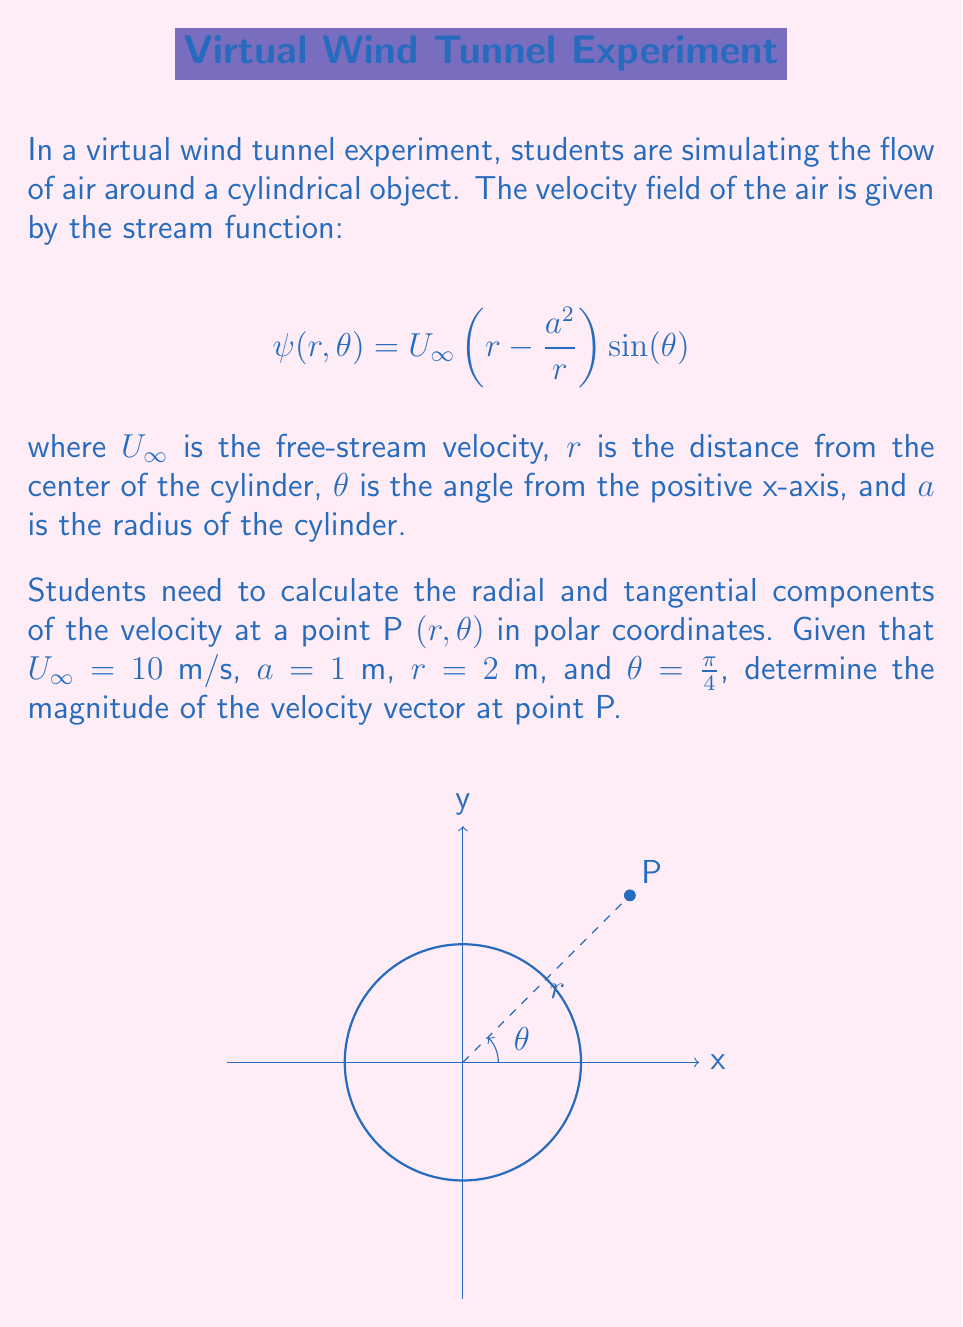Help me with this question. To solve this problem, we'll follow these steps:

1) First, recall that the radial and tangential components of velocity can be derived from the stream function as follows:

   $$v_r = -\frac{1}{r} \frac{\partial \psi}{\partial \theta}$$
   $$v_\theta = \frac{\partial \psi}{\partial r}$$

2) Let's calculate $v_r$:
   
   $$\frac{\partial \psi}{\partial \theta} = U_\infty \left(r - \frac{a^2}{r}\right) \cos(\theta)$$
   
   $$v_r = -\frac{1}{r} U_\infty \left(r - \frac{a^2}{r}\right) \cos(\theta)$$
   
   $$v_r = -U_\infty \left(1 - \frac{a^2}{r^2}\right) \cos(\theta)$$

3) Now, let's calculate $v_\theta$:
   
   $$\frac{\partial \psi}{\partial r} = U_\infty \left(1 + \frac{a^2}{r^2}\right) \sin(\theta)$$
   
   $$v_\theta = U_\infty \left(1 + \frac{a^2}{r^2}\right) \sin(\theta)$$

4) Substituting the given values: $U_\infty = 10$ m/s, $a = 1$ m, $r = 2$ m, and $\theta = \frac{\pi}{4}$:

   $$v_r = -10 \left(1 - \frac{1^2}{2^2}\right) \cos(\frac{\pi}{4}) = -7.5 \cdot \frac{\sqrt{2}}{2} = -5.303 \text{ m/s}$$
   
   $$v_\theta = 10 \left(1 + \frac{1^2}{2^2}\right) \sin(\frac{\pi}{4}) = 12.5 \cdot \frac{\sqrt{2}}{2} = 8.839 \text{ m/s}$$

5) The magnitude of the velocity vector is given by:

   $$|\vec{v}| = \sqrt{v_r^2 + v_\theta^2}$$

6) Substituting the values:

   $$|\vec{v}| = \sqrt{(-5.303)^2 + (8.839)^2} = \sqrt{28.122 + 78.128} = \sqrt{106.25} = 10.308 \text{ m/s}$$

Therefore, the magnitude of the velocity vector at point P is approximately 10.308 m/s.
Answer: 10.308 m/s 